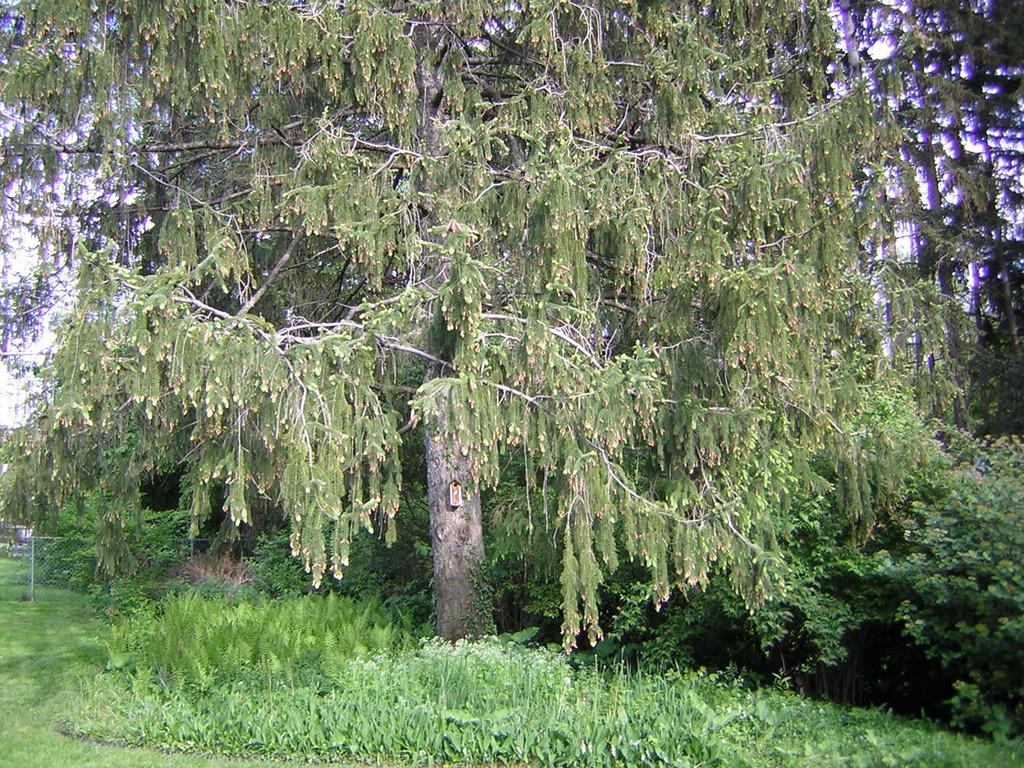What type of surface is visible at the bottom of the image? There is grass on the surface at the bottom of the image. What is located at the center of the image? There is a metal fence at the center of the image. What can be seen in the background of the image? There are trees and the sky visible in the background of the image. How many donkeys are grazing in the grass in the image? There are no donkeys present in the image; it features grass, a metal fence, trees, and the sky. What year is depicted in the image? The image does not depict a specific year; it is a photograph of a natural scene. 